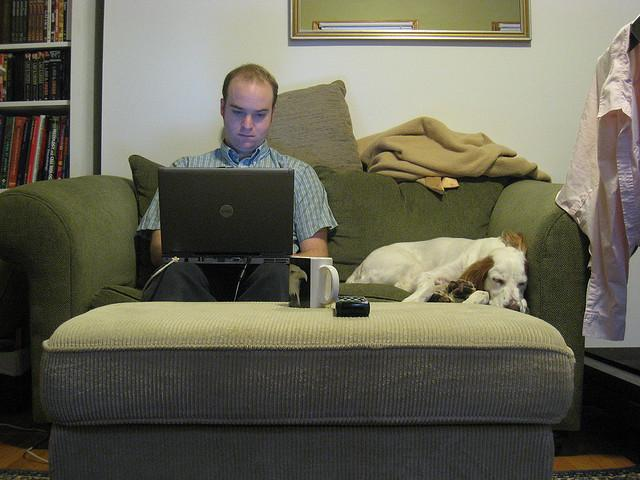What type of potentially harmful light does the laptop screen produce? blue light 